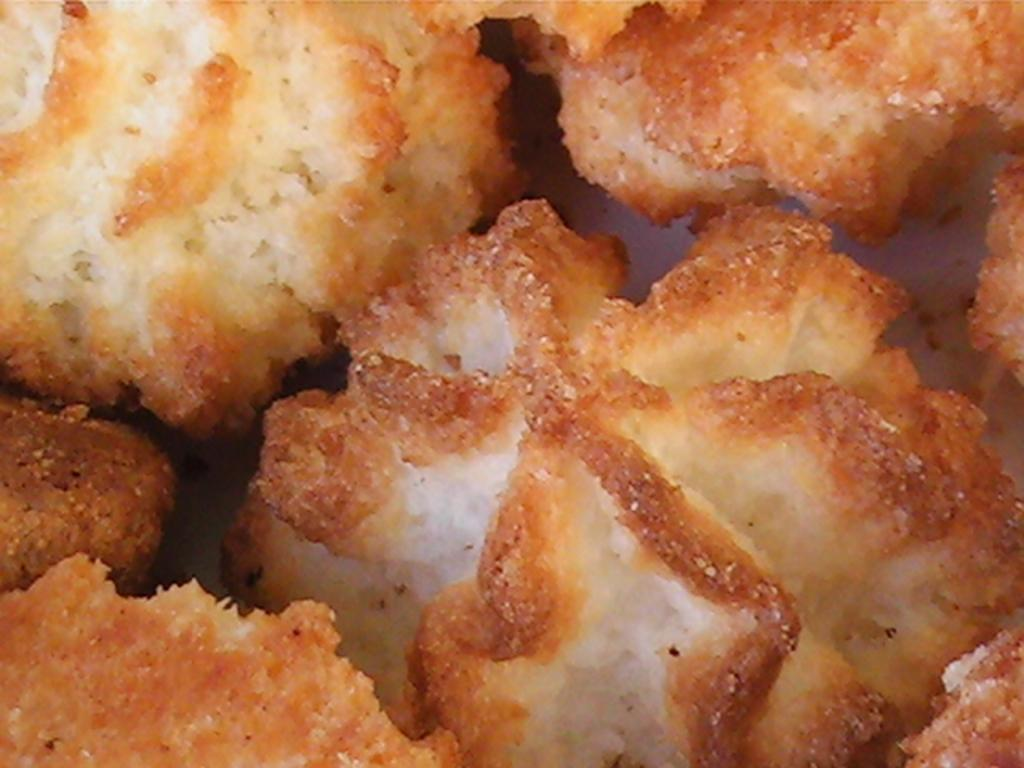What can be seen on the surface in the image? There is food placed on a surface in the image. Can you describe the food in more detail? Unfortunately, the facts provided do not give any specific details about the food. What type of surface is the food placed on? The facts provided do not specify the type of surface. How many rings are visible on the dirt in the image? There is no dirt or rings present in the image; it only features food placed on a surface. 